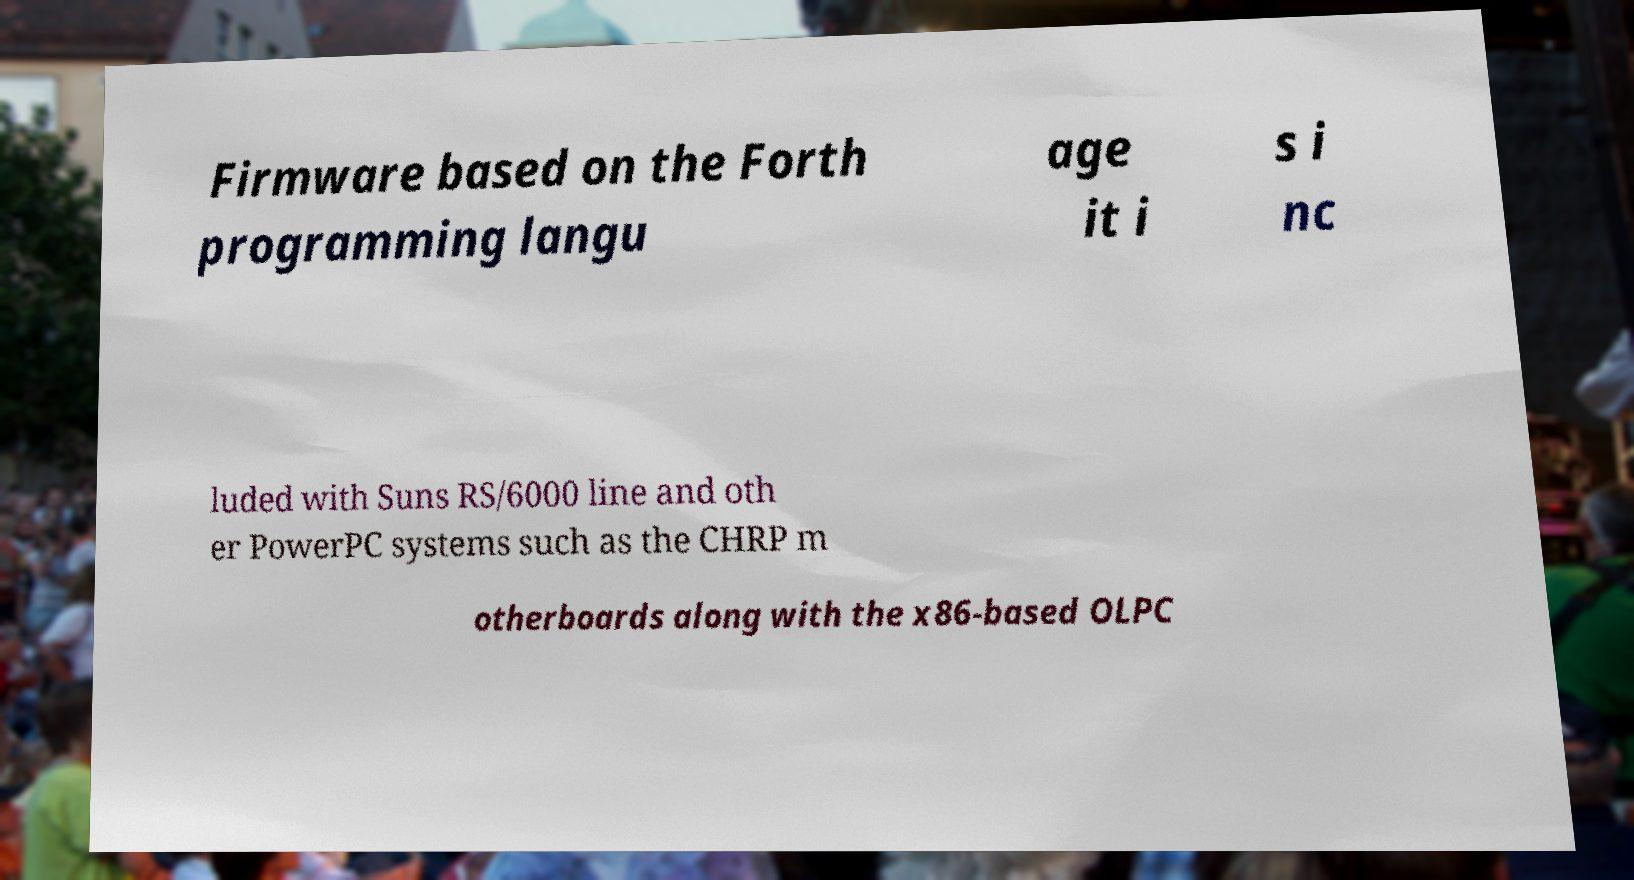What messages or text are displayed in this image? I need them in a readable, typed format. Firmware based on the Forth programming langu age it i s i nc luded with Suns RS/6000 line and oth er PowerPC systems such as the CHRP m otherboards along with the x86-based OLPC 